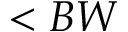<formula> <loc_0><loc_0><loc_500><loc_500>< B W</formula> 